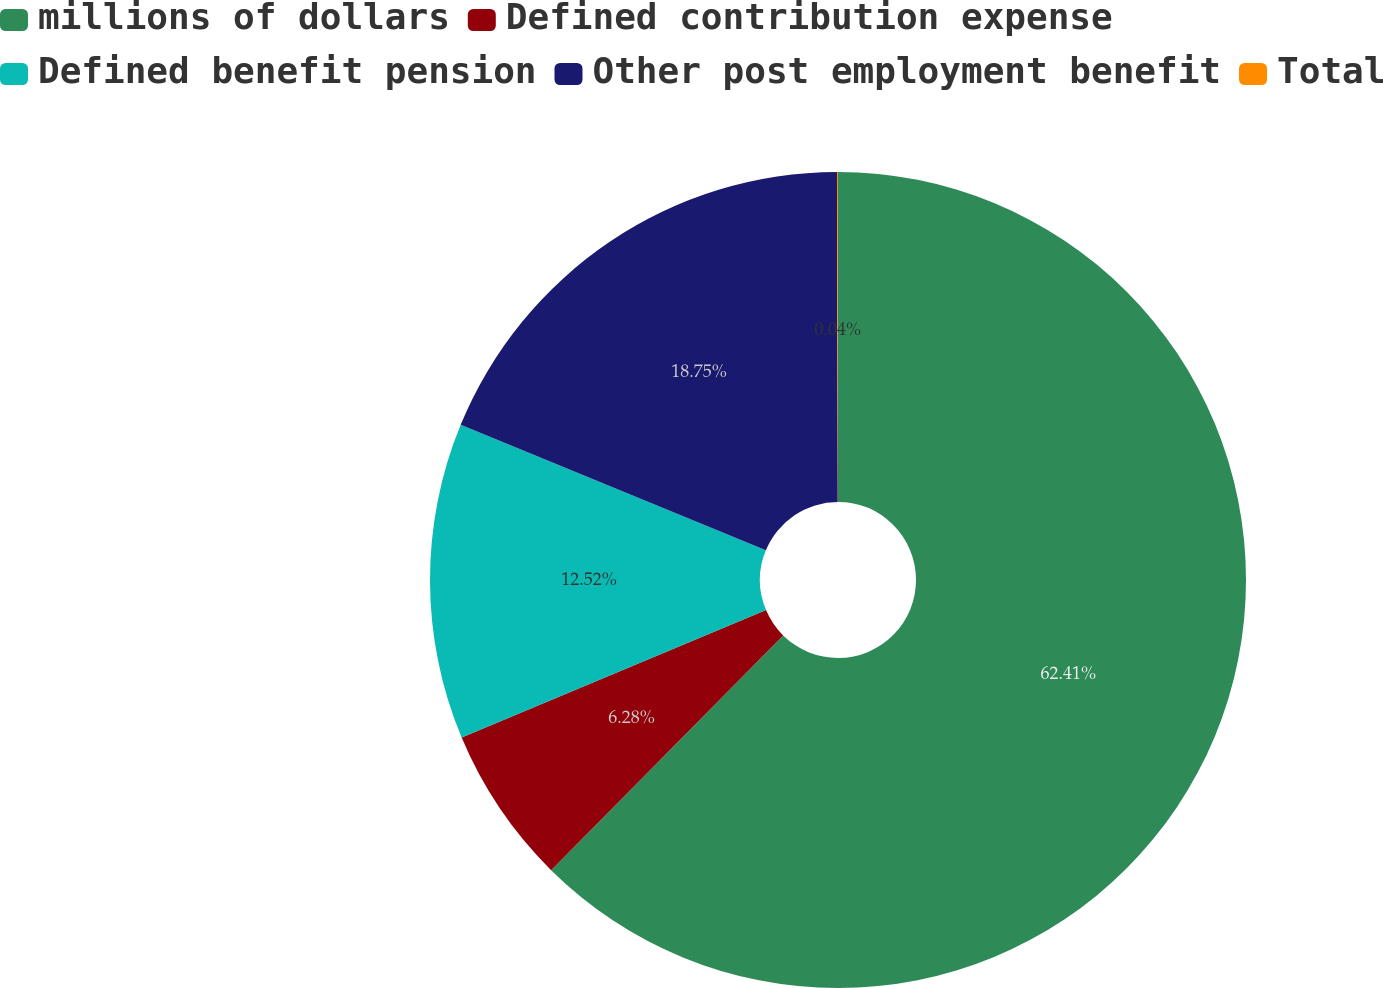Convert chart to OTSL. <chart><loc_0><loc_0><loc_500><loc_500><pie_chart><fcel>millions of dollars<fcel>Defined contribution expense<fcel>Defined benefit pension<fcel>Other post employment benefit<fcel>Total<nl><fcel>62.41%<fcel>6.28%<fcel>12.52%<fcel>18.75%<fcel>0.04%<nl></chart> 